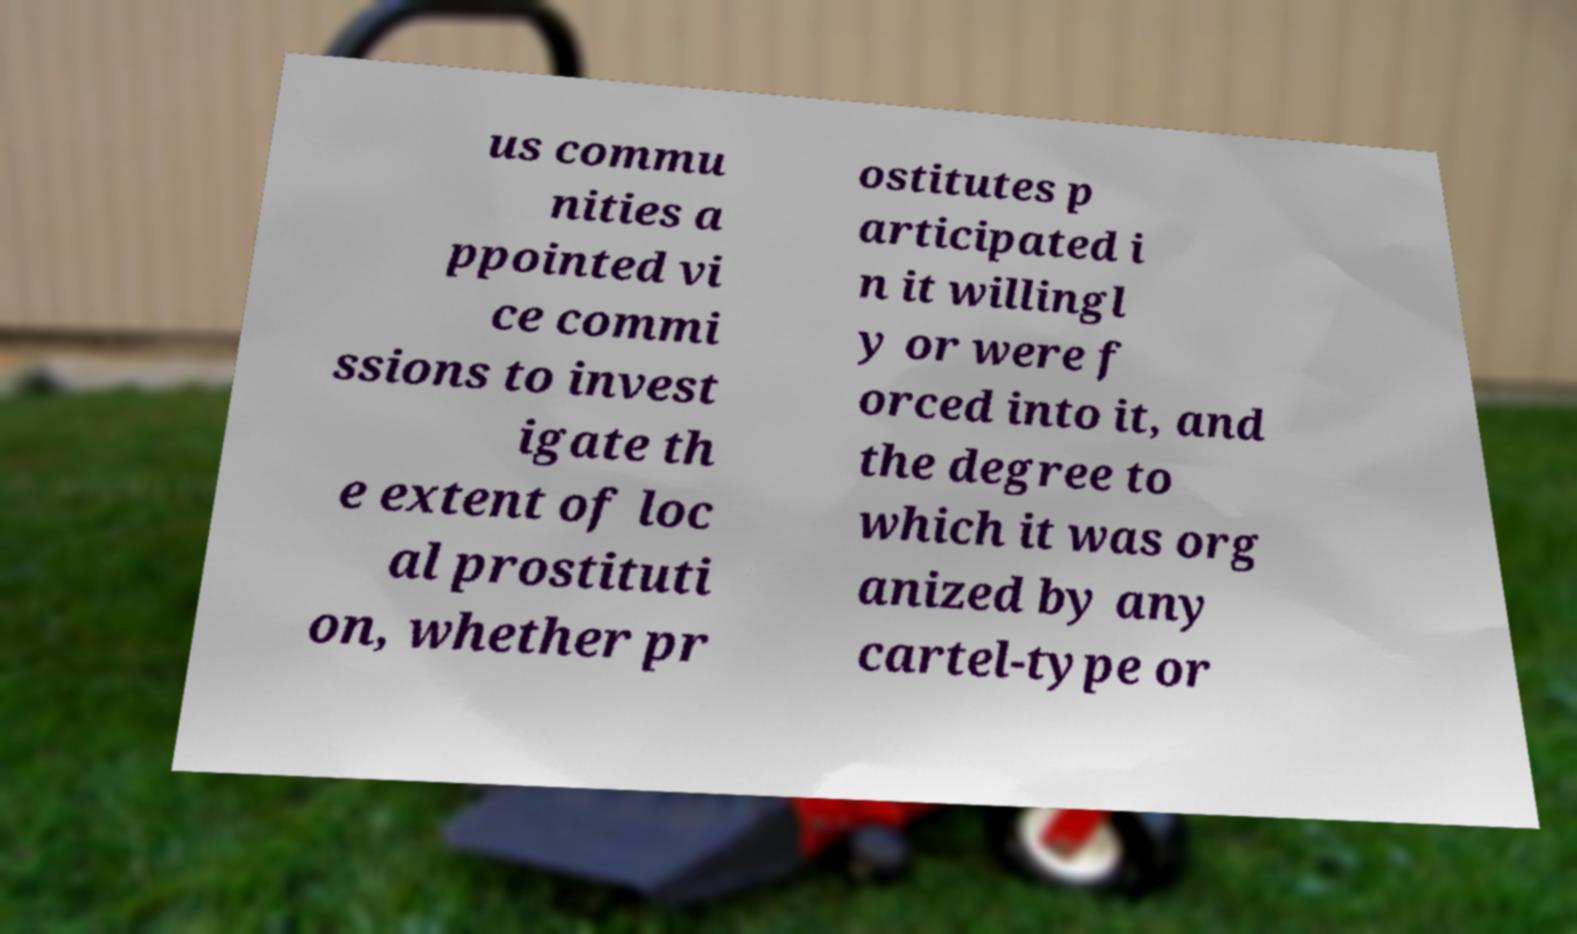Please identify and transcribe the text found in this image. us commu nities a ppointed vi ce commi ssions to invest igate th e extent of loc al prostituti on, whether pr ostitutes p articipated i n it willingl y or were f orced into it, and the degree to which it was org anized by any cartel-type or 